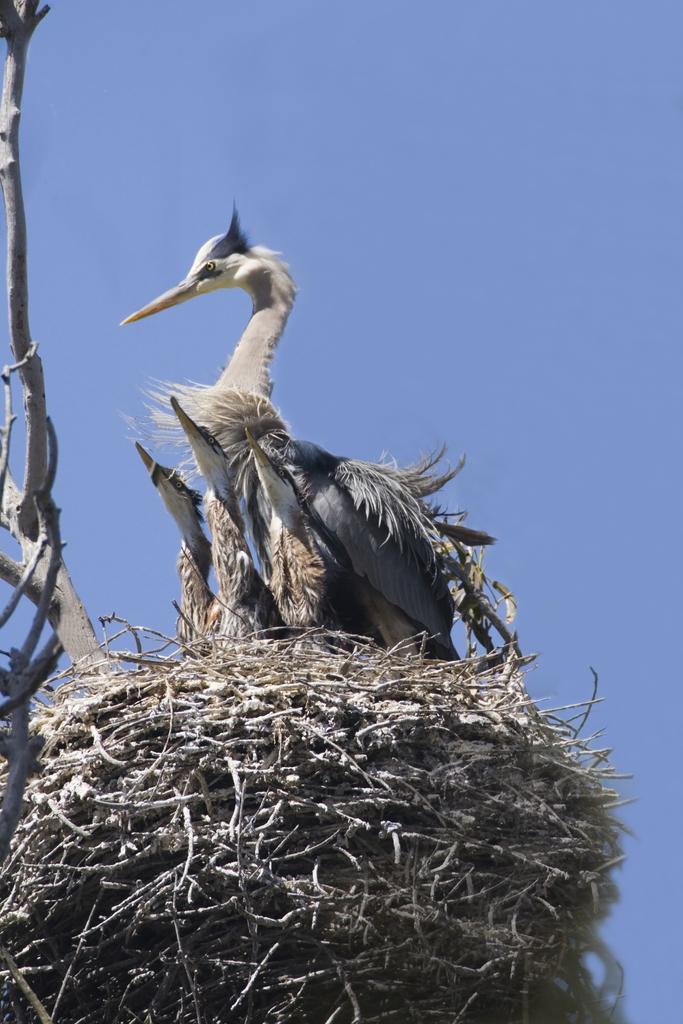Please provide a concise description of this image. In this image I can see a bird nest on the tree and I can see few birds which are brown, cream, black and white in color. In the background I can see the sky. 